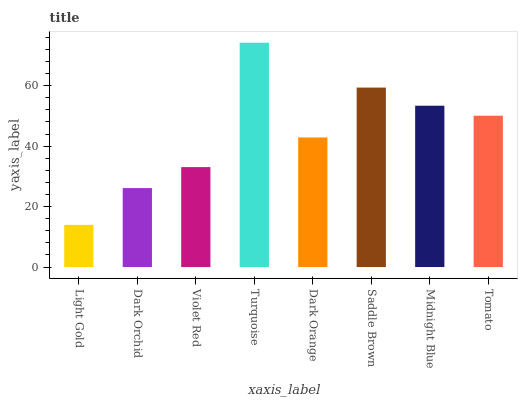Is Light Gold the minimum?
Answer yes or no. Yes. Is Turquoise the maximum?
Answer yes or no. Yes. Is Dark Orchid the minimum?
Answer yes or no. No. Is Dark Orchid the maximum?
Answer yes or no. No. Is Dark Orchid greater than Light Gold?
Answer yes or no. Yes. Is Light Gold less than Dark Orchid?
Answer yes or no. Yes. Is Light Gold greater than Dark Orchid?
Answer yes or no. No. Is Dark Orchid less than Light Gold?
Answer yes or no. No. Is Tomato the high median?
Answer yes or no. Yes. Is Dark Orange the low median?
Answer yes or no. Yes. Is Turquoise the high median?
Answer yes or no. No. Is Violet Red the low median?
Answer yes or no. No. 